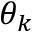<formula> <loc_0><loc_0><loc_500><loc_500>\theta _ { k }</formula> 